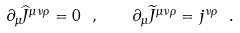Convert formula to latex. <formula><loc_0><loc_0><loc_500><loc_500>\partial _ { \mu } \widehat { J } ^ { \mu \nu \rho } = 0 \ , \quad \partial _ { \mu } \widetilde { J } ^ { \mu \nu \rho } = j ^ { \nu \rho } \ .</formula> 